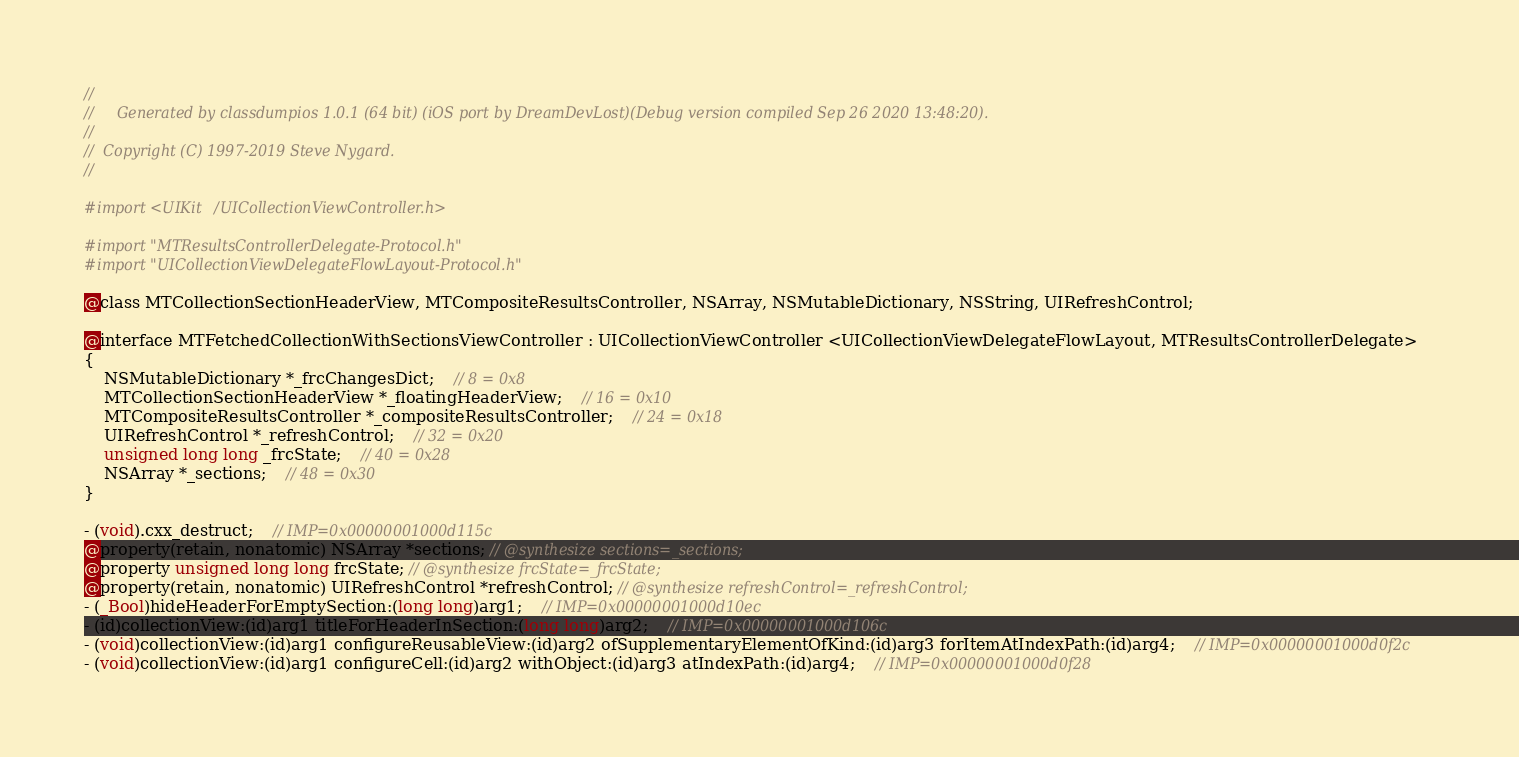<code> <loc_0><loc_0><loc_500><loc_500><_C_>//
//     Generated by classdumpios 1.0.1 (64 bit) (iOS port by DreamDevLost)(Debug version compiled Sep 26 2020 13:48:20).
//
//  Copyright (C) 1997-2019 Steve Nygard.
//

#import <UIKit/UICollectionViewController.h>

#import "MTResultsControllerDelegate-Protocol.h"
#import "UICollectionViewDelegateFlowLayout-Protocol.h"

@class MTCollectionSectionHeaderView, MTCompositeResultsController, NSArray, NSMutableDictionary, NSString, UIRefreshControl;

@interface MTFetchedCollectionWithSectionsViewController : UICollectionViewController <UICollectionViewDelegateFlowLayout, MTResultsControllerDelegate>
{
    NSMutableDictionary *_frcChangesDict;	// 8 = 0x8
    MTCollectionSectionHeaderView *_floatingHeaderView;	// 16 = 0x10
    MTCompositeResultsController *_compositeResultsController;	// 24 = 0x18
    UIRefreshControl *_refreshControl;	// 32 = 0x20
    unsigned long long _frcState;	// 40 = 0x28
    NSArray *_sections;	// 48 = 0x30
}

- (void).cxx_destruct;	// IMP=0x00000001000d115c
@property(retain, nonatomic) NSArray *sections; // @synthesize sections=_sections;
@property unsigned long long frcState; // @synthesize frcState=_frcState;
@property(retain, nonatomic) UIRefreshControl *refreshControl; // @synthesize refreshControl=_refreshControl;
- (_Bool)hideHeaderForEmptySection:(long long)arg1;	// IMP=0x00000001000d10ec
- (id)collectionView:(id)arg1 titleForHeaderInSection:(long long)arg2;	// IMP=0x00000001000d106c
- (void)collectionView:(id)arg1 configureReusableView:(id)arg2 ofSupplementaryElementOfKind:(id)arg3 forItemAtIndexPath:(id)arg4;	// IMP=0x00000001000d0f2c
- (void)collectionView:(id)arg1 configureCell:(id)arg2 withObject:(id)arg3 atIndexPath:(id)arg4;	// IMP=0x00000001000d0f28</code> 